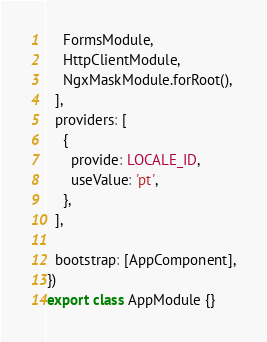Convert code to text. <code><loc_0><loc_0><loc_500><loc_500><_TypeScript_>    FormsModule,
    HttpClientModule,
    NgxMaskModule.forRoot(),
  ],
  providers: [
    {
      provide: LOCALE_ID,
      useValue: 'pt',
    },
  ],

  bootstrap: [AppComponent],
})
export class AppModule {}
</code> 